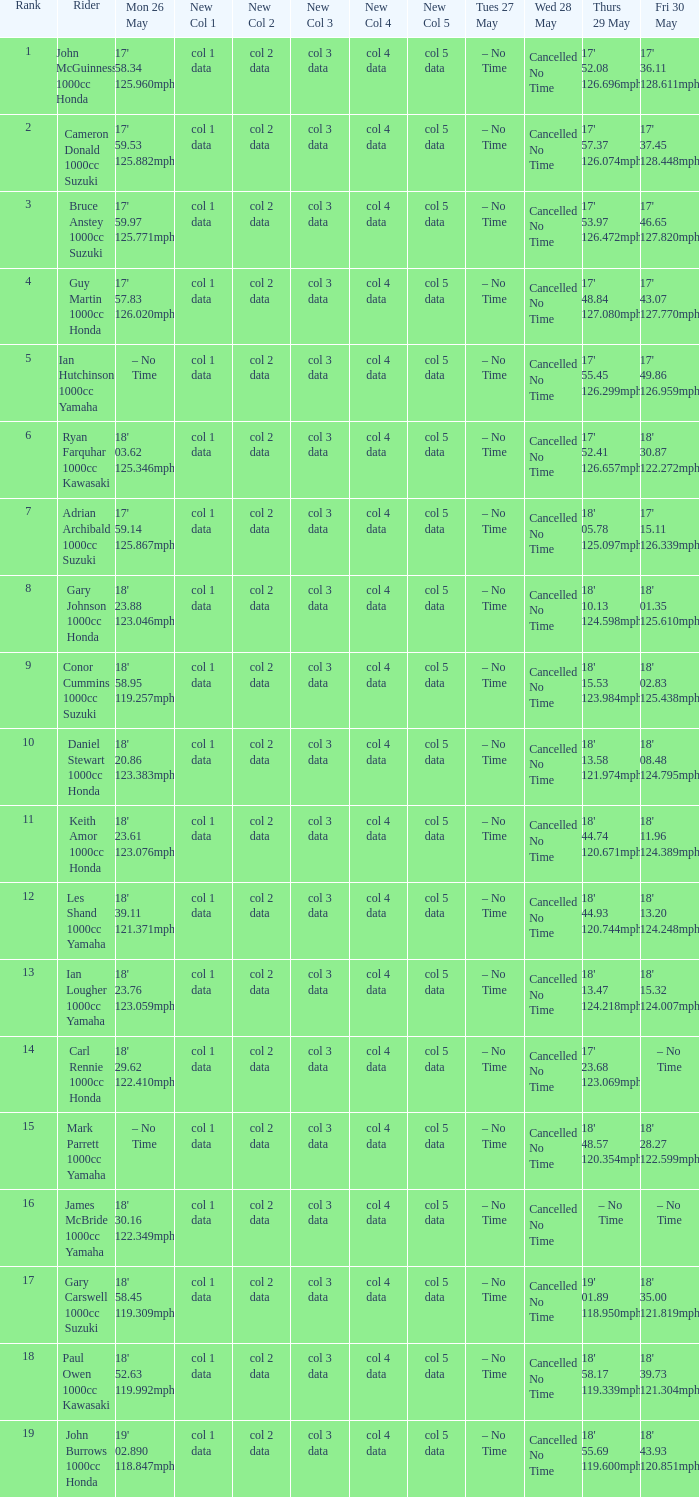What time is mon may 26 and fri may 30 is 18' 28.27 122.599mph? – No Time. 